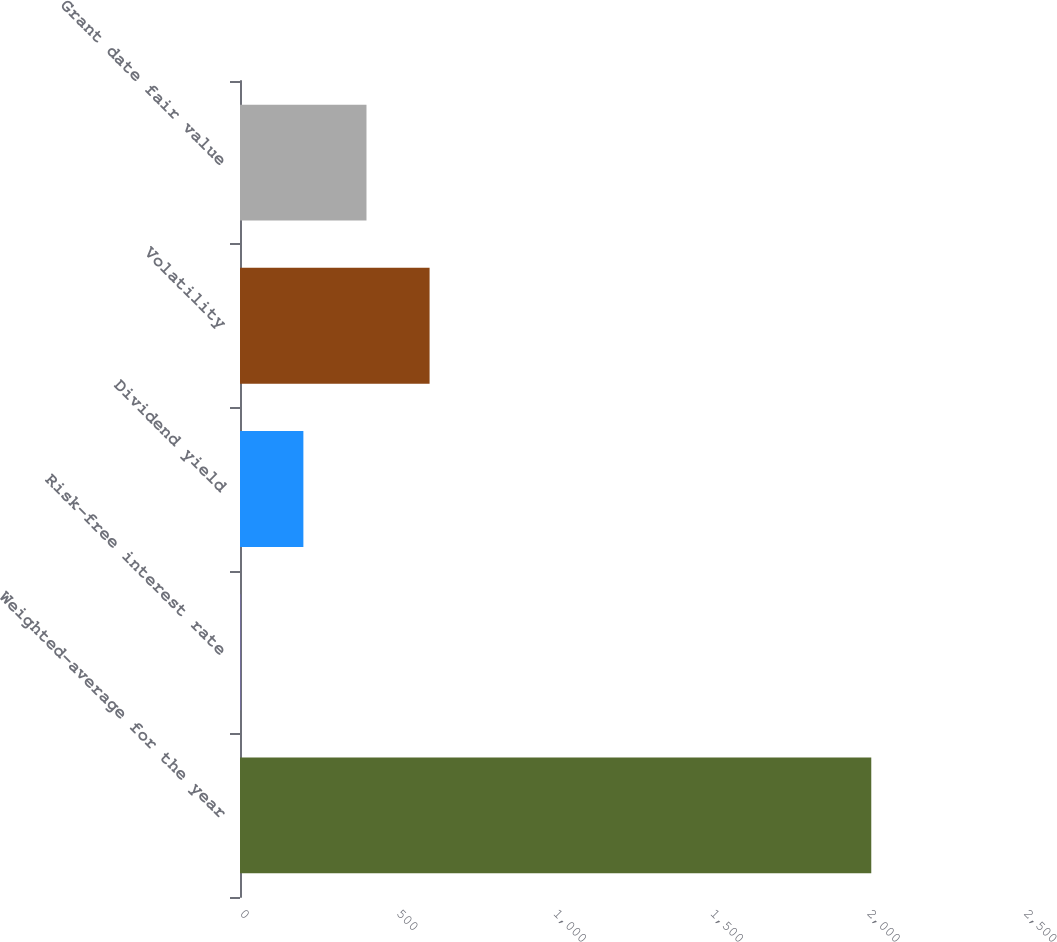Convert chart to OTSL. <chart><loc_0><loc_0><loc_500><loc_500><bar_chart><fcel>Weighted-average for the year<fcel>Risk-free interest rate<fcel>Dividend yield<fcel>Volatility<fcel>Grant date fair value<nl><fcel>2013<fcel>0.9<fcel>202.11<fcel>604.53<fcel>403.32<nl></chart> 